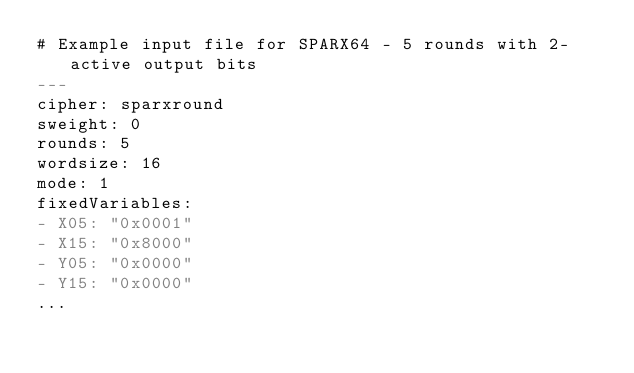Convert code to text. <code><loc_0><loc_0><loc_500><loc_500><_YAML_># Example input file for SPARX64 - 5 rounds with 2-active output bits
---
cipher: sparxround
sweight: 0
rounds: 5
wordsize: 16
mode: 1
fixedVariables:
- X05: "0x0001"
- X15: "0x8000"
- Y05: "0x0000"
- Y15: "0x0000"
...

</code> 